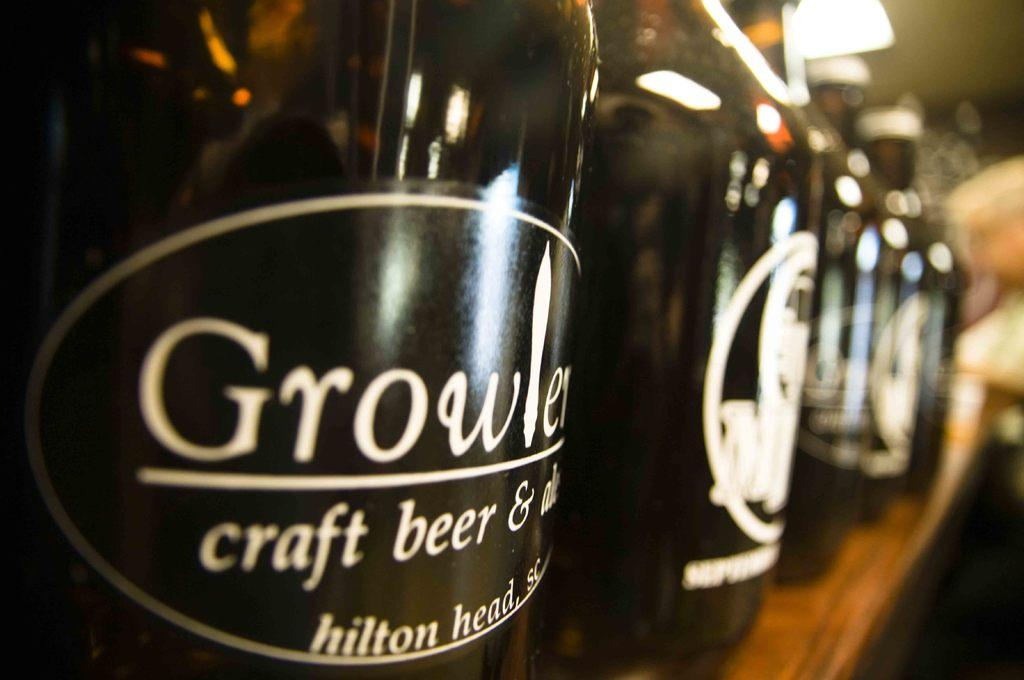What objects are present in the image? There are bottles in the image. What is the color of the surface on which the bottles are placed? The bottles are on a brown color surface. Can you describe the background of the image? The background of the image is blurred. Is there a girl pushing a wheel in the image? No, there is no girl or wheel present in the image. 